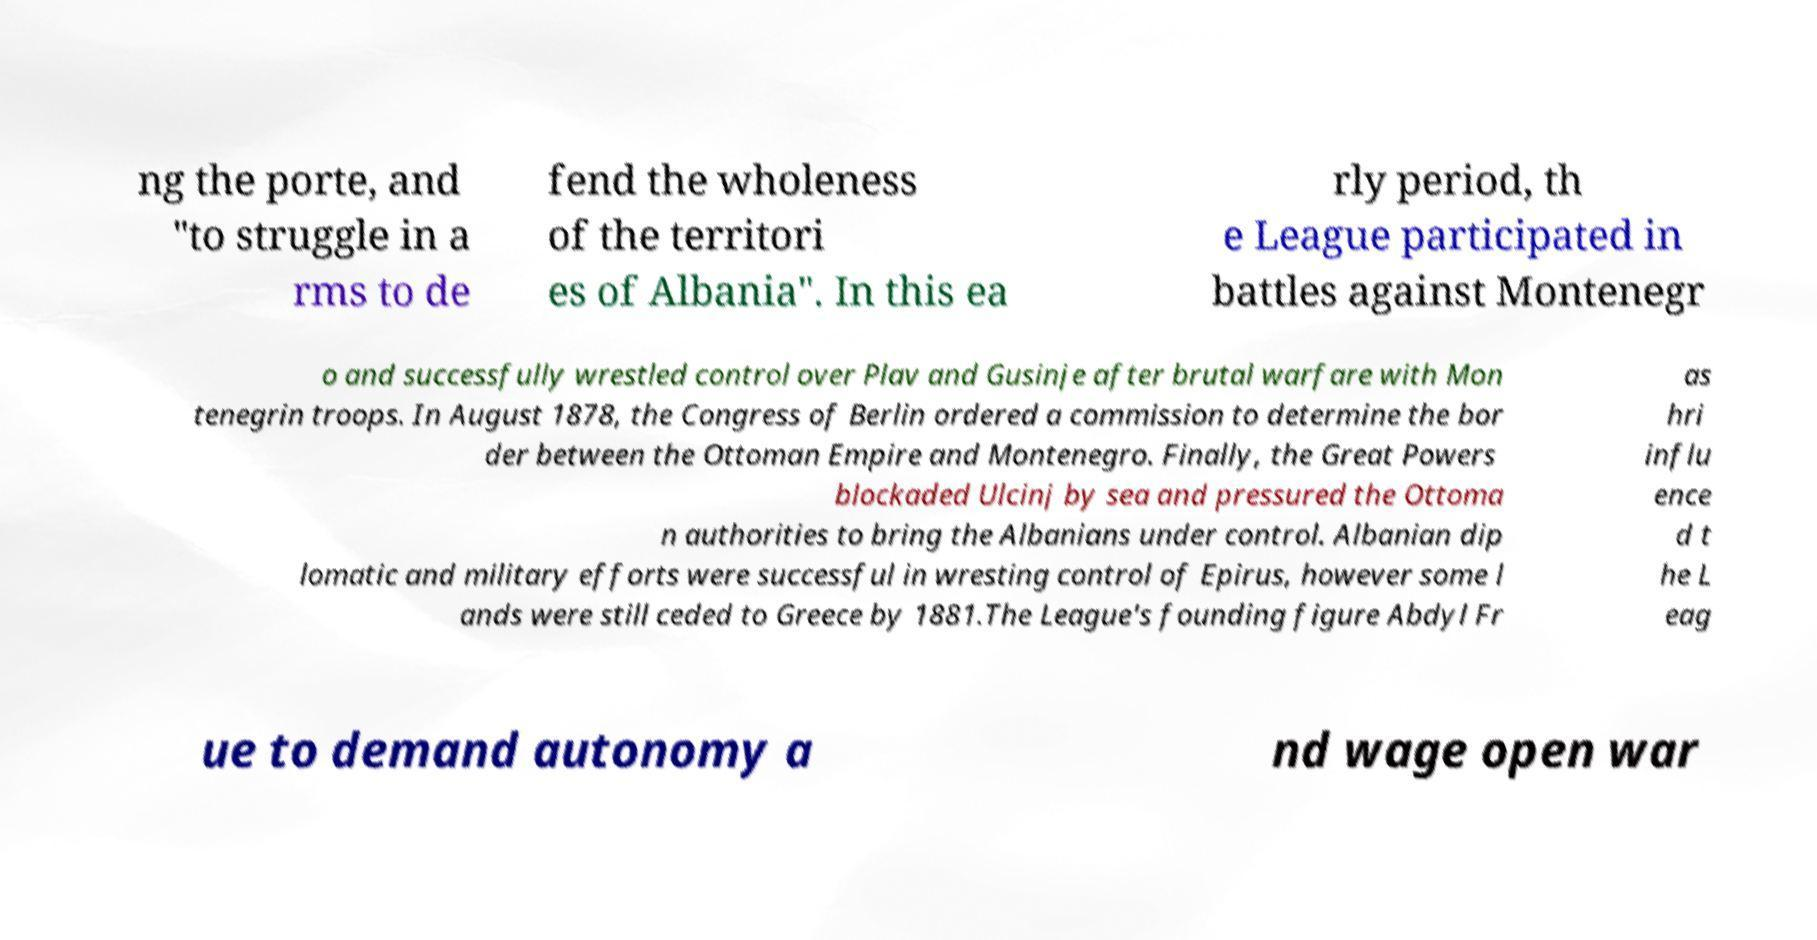Could you extract and type out the text from this image? ng the porte, and "to struggle in a rms to de fend the wholeness of the territori es of Albania". In this ea rly period, th e League participated in battles against Montenegr o and successfully wrestled control over Plav and Gusinje after brutal warfare with Mon tenegrin troops. In August 1878, the Congress of Berlin ordered a commission to determine the bor der between the Ottoman Empire and Montenegro. Finally, the Great Powers blockaded Ulcinj by sea and pressured the Ottoma n authorities to bring the Albanians under control. Albanian dip lomatic and military efforts were successful in wresting control of Epirus, however some l ands were still ceded to Greece by 1881.The League's founding figure Abdyl Fr as hri influ ence d t he L eag ue to demand autonomy a nd wage open war 